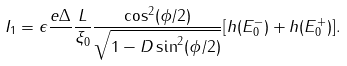Convert formula to latex. <formula><loc_0><loc_0><loc_500><loc_500>I _ { 1 } = \epsilon \frac { e \Delta } { } \frac { L } { \xi _ { 0 } } \frac { \cos ^ { 2 } ( \phi / 2 ) } { \sqrt { 1 - D \sin ^ { 2 } ( \phi / 2 ) } } [ h ( E _ { 0 } ^ { - } ) + h ( E _ { 0 } ^ { + } ) ] .</formula> 